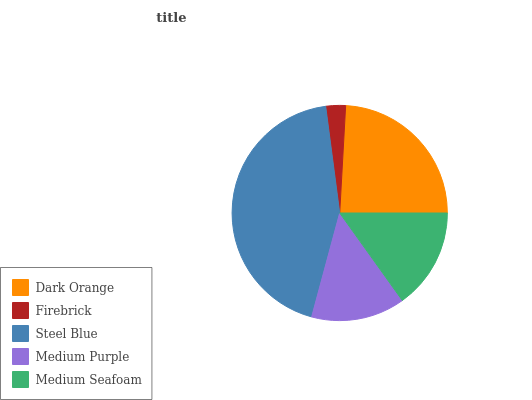Is Firebrick the minimum?
Answer yes or no. Yes. Is Steel Blue the maximum?
Answer yes or no. Yes. Is Steel Blue the minimum?
Answer yes or no. No. Is Firebrick the maximum?
Answer yes or no. No. Is Steel Blue greater than Firebrick?
Answer yes or no. Yes. Is Firebrick less than Steel Blue?
Answer yes or no. Yes. Is Firebrick greater than Steel Blue?
Answer yes or no. No. Is Steel Blue less than Firebrick?
Answer yes or no. No. Is Medium Seafoam the high median?
Answer yes or no. Yes. Is Medium Seafoam the low median?
Answer yes or no. Yes. Is Medium Purple the high median?
Answer yes or no. No. Is Steel Blue the low median?
Answer yes or no. No. 